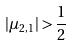<formula> <loc_0><loc_0><loc_500><loc_500>| \mu _ { 2 , 1 } | > \frac { 1 } { 2 }</formula> 